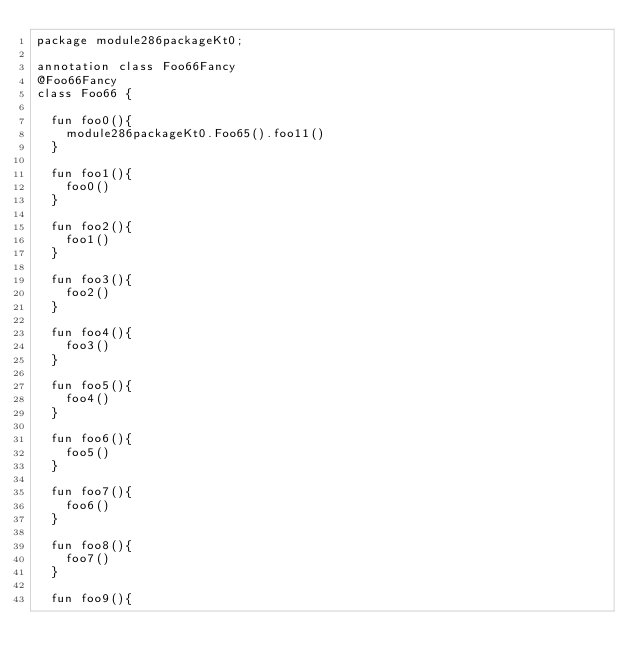Convert code to text. <code><loc_0><loc_0><loc_500><loc_500><_Kotlin_>package module286packageKt0;

annotation class Foo66Fancy
@Foo66Fancy
class Foo66 {

  fun foo0(){
    module286packageKt0.Foo65().foo11()
  }

  fun foo1(){
    foo0()
  }

  fun foo2(){
    foo1()
  }

  fun foo3(){
    foo2()
  }

  fun foo4(){
    foo3()
  }

  fun foo5(){
    foo4()
  }

  fun foo6(){
    foo5()
  }

  fun foo7(){
    foo6()
  }

  fun foo8(){
    foo7()
  }

  fun foo9(){</code> 